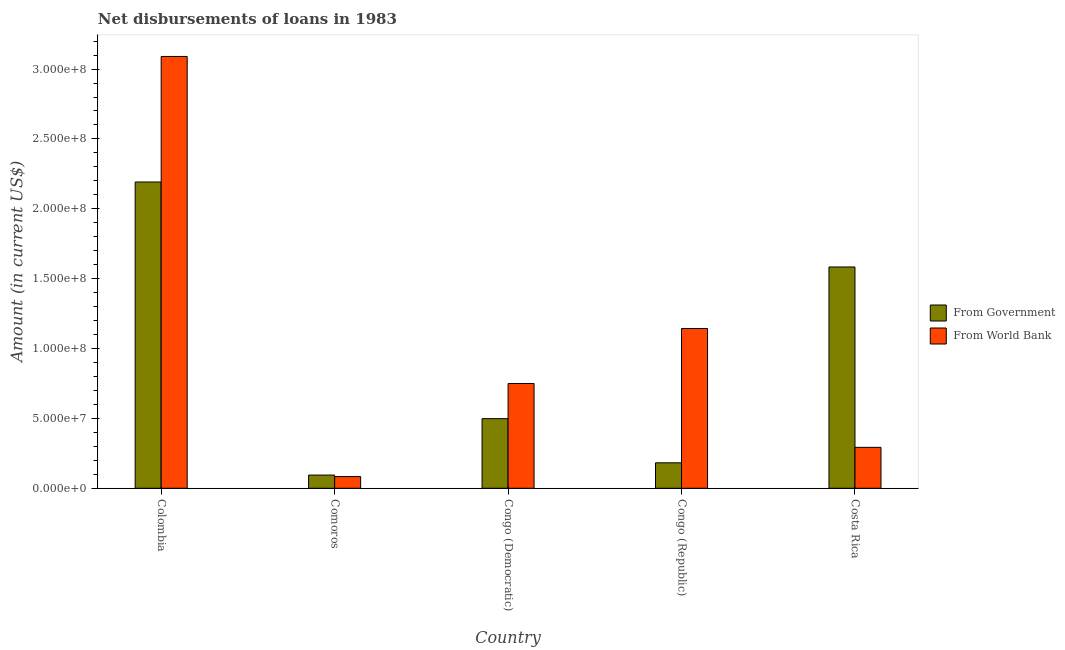How many groups of bars are there?
Your answer should be very brief. 5. Are the number of bars on each tick of the X-axis equal?
Offer a terse response. Yes. How many bars are there on the 3rd tick from the left?
Keep it short and to the point. 2. What is the label of the 4th group of bars from the left?
Your response must be concise. Congo (Republic). In how many cases, is the number of bars for a given country not equal to the number of legend labels?
Ensure brevity in your answer.  0. What is the net disbursements of loan from government in Colombia?
Provide a short and direct response. 2.19e+08. Across all countries, what is the maximum net disbursements of loan from world bank?
Your answer should be very brief. 3.09e+08. Across all countries, what is the minimum net disbursements of loan from world bank?
Offer a very short reply. 8.38e+06. In which country was the net disbursements of loan from world bank maximum?
Your answer should be compact. Colombia. In which country was the net disbursements of loan from government minimum?
Provide a succinct answer. Comoros. What is the total net disbursements of loan from world bank in the graph?
Give a very brief answer. 5.36e+08. What is the difference between the net disbursements of loan from government in Congo (Democratic) and that in Costa Rica?
Give a very brief answer. -1.09e+08. What is the difference between the net disbursements of loan from world bank in Congo (Republic) and the net disbursements of loan from government in Costa Rica?
Provide a succinct answer. -4.40e+07. What is the average net disbursements of loan from world bank per country?
Provide a short and direct response. 1.07e+08. What is the difference between the net disbursements of loan from government and net disbursements of loan from world bank in Comoros?
Offer a terse response. 1.07e+06. What is the ratio of the net disbursements of loan from world bank in Comoros to that in Congo (Democratic)?
Give a very brief answer. 0.11. Is the net disbursements of loan from government in Congo (Democratic) less than that in Congo (Republic)?
Offer a terse response. No. Is the difference between the net disbursements of loan from government in Congo (Republic) and Costa Rica greater than the difference between the net disbursements of loan from world bank in Congo (Republic) and Costa Rica?
Offer a terse response. No. What is the difference between the highest and the second highest net disbursements of loan from government?
Offer a terse response. 6.08e+07. What is the difference between the highest and the lowest net disbursements of loan from government?
Your response must be concise. 2.10e+08. What does the 1st bar from the left in Colombia represents?
Ensure brevity in your answer.  From Government. What does the 1st bar from the right in Congo (Republic) represents?
Your response must be concise. From World Bank. How many countries are there in the graph?
Provide a succinct answer. 5. What is the difference between two consecutive major ticks on the Y-axis?
Offer a terse response. 5.00e+07. Are the values on the major ticks of Y-axis written in scientific E-notation?
Offer a terse response. Yes. Does the graph contain grids?
Provide a succinct answer. No. How are the legend labels stacked?
Offer a terse response. Vertical. What is the title of the graph?
Provide a short and direct response. Net disbursements of loans in 1983. What is the Amount (in current US$) in From Government in Colombia?
Make the answer very short. 2.19e+08. What is the Amount (in current US$) in From World Bank in Colombia?
Provide a short and direct response. 3.09e+08. What is the Amount (in current US$) in From Government in Comoros?
Keep it short and to the point. 9.45e+06. What is the Amount (in current US$) in From World Bank in Comoros?
Keep it short and to the point. 8.38e+06. What is the Amount (in current US$) in From Government in Congo (Democratic)?
Keep it short and to the point. 4.98e+07. What is the Amount (in current US$) of From World Bank in Congo (Democratic)?
Give a very brief answer. 7.50e+07. What is the Amount (in current US$) in From Government in Congo (Republic)?
Your answer should be very brief. 1.82e+07. What is the Amount (in current US$) of From World Bank in Congo (Republic)?
Make the answer very short. 1.14e+08. What is the Amount (in current US$) in From Government in Costa Rica?
Keep it short and to the point. 1.58e+08. What is the Amount (in current US$) of From World Bank in Costa Rica?
Provide a succinct answer. 2.93e+07. Across all countries, what is the maximum Amount (in current US$) of From Government?
Your answer should be very brief. 2.19e+08. Across all countries, what is the maximum Amount (in current US$) of From World Bank?
Your response must be concise. 3.09e+08. Across all countries, what is the minimum Amount (in current US$) in From Government?
Offer a very short reply. 9.45e+06. Across all countries, what is the minimum Amount (in current US$) in From World Bank?
Give a very brief answer. 8.38e+06. What is the total Amount (in current US$) of From Government in the graph?
Your answer should be very brief. 4.55e+08. What is the total Amount (in current US$) of From World Bank in the graph?
Make the answer very short. 5.36e+08. What is the difference between the Amount (in current US$) in From Government in Colombia and that in Comoros?
Your response must be concise. 2.10e+08. What is the difference between the Amount (in current US$) of From World Bank in Colombia and that in Comoros?
Offer a terse response. 3.01e+08. What is the difference between the Amount (in current US$) in From Government in Colombia and that in Congo (Democratic)?
Provide a short and direct response. 1.69e+08. What is the difference between the Amount (in current US$) of From World Bank in Colombia and that in Congo (Democratic)?
Offer a very short reply. 2.34e+08. What is the difference between the Amount (in current US$) of From Government in Colombia and that in Congo (Republic)?
Provide a short and direct response. 2.01e+08. What is the difference between the Amount (in current US$) in From World Bank in Colombia and that in Congo (Republic)?
Ensure brevity in your answer.  1.95e+08. What is the difference between the Amount (in current US$) in From Government in Colombia and that in Costa Rica?
Your response must be concise. 6.08e+07. What is the difference between the Amount (in current US$) of From World Bank in Colombia and that in Costa Rica?
Ensure brevity in your answer.  2.80e+08. What is the difference between the Amount (in current US$) of From Government in Comoros and that in Congo (Democratic)?
Provide a succinct answer. -4.04e+07. What is the difference between the Amount (in current US$) of From World Bank in Comoros and that in Congo (Democratic)?
Make the answer very short. -6.66e+07. What is the difference between the Amount (in current US$) of From Government in Comoros and that in Congo (Republic)?
Ensure brevity in your answer.  -8.77e+06. What is the difference between the Amount (in current US$) in From World Bank in Comoros and that in Congo (Republic)?
Keep it short and to the point. -1.06e+08. What is the difference between the Amount (in current US$) in From Government in Comoros and that in Costa Rica?
Keep it short and to the point. -1.49e+08. What is the difference between the Amount (in current US$) of From World Bank in Comoros and that in Costa Rica?
Provide a succinct answer. -2.09e+07. What is the difference between the Amount (in current US$) in From Government in Congo (Democratic) and that in Congo (Republic)?
Keep it short and to the point. 3.16e+07. What is the difference between the Amount (in current US$) of From World Bank in Congo (Democratic) and that in Congo (Republic)?
Your response must be concise. -3.93e+07. What is the difference between the Amount (in current US$) in From Government in Congo (Democratic) and that in Costa Rica?
Ensure brevity in your answer.  -1.09e+08. What is the difference between the Amount (in current US$) of From World Bank in Congo (Democratic) and that in Costa Rica?
Provide a succinct answer. 4.57e+07. What is the difference between the Amount (in current US$) in From Government in Congo (Republic) and that in Costa Rica?
Ensure brevity in your answer.  -1.40e+08. What is the difference between the Amount (in current US$) in From World Bank in Congo (Republic) and that in Costa Rica?
Your answer should be compact. 8.50e+07. What is the difference between the Amount (in current US$) in From Government in Colombia and the Amount (in current US$) in From World Bank in Comoros?
Provide a succinct answer. 2.11e+08. What is the difference between the Amount (in current US$) of From Government in Colombia and the Amount (in current US$) of From World Bank in Congo (Democratic)?
Your response must be concise. 1.44e+08. What is the difference between the Amount (in current US$) of From Government in Colombia and the Amount (in current US$) of From World Bank in Congo (Republic)?
Your answer should be compact. 1.05e+08. What is the difference between the Amount (in current US$) of From Government in Colombia and the Amount (in current US$) of From World Bank in Costa Rica?
Offer a very short reply. 1.90e+08. What is the difference between the Amount (in current US$) of From Government in Comoros and the Amount (in current US$) of From World Bank in Congo (Democratic)?
Make the answer very short. -6.55e+07. What is the difference between the Amount (in current US$) in From Government in Comoros and the Amount (in current US$) in From World Bank in Congo (Republic)?
Provide a succinct answer. -1.05e+08. What is the difference between the Amount (in current US$) in From Government in Comoros and the Amount (in current US$) in From World Bank in Costa Rica?
Offer a terse response. -1.98e+07. What is the difference between the Amount (in current US$) in From Government in Congo (Democratic) and the Amount (in current US$) in From World Bank in Congo (Republic)?
Your answer should be very brief. -6.45e+07. What is the difference between the Amount (in current US$) of From Government in Congo (Democratic) and the Amount (in current US$) of From World Bank in Costa Rica?
Provide a short and direct response. 2.05e+07. What is the difference between the Amount (in current US$) of From Government in Congo (Republic) and the Amount (in current US$) of From World Bank in Costa Rica?
Your answer should be very brief. -1.11e+07. What is the average Amount (in current US$) of From Government per country?
Keep it short and to the point. 9.10e+07. What is the average Amount (in current US$) of From World Bank per country?
Offer a terse response. 1.07e+08. What is the difference between the Amount (in current US$) in From Government and Amount (in current US$) in From World Bank in Colombia?
Your response must be concise. -8.98e+07. What is the difference between the Amount (in current US$) of From Government and Amount (in current US$) of From World Bank in Comoros?
Your answer should be very brief. 1.07e+06. What is the difference between the Amount (in current US$) in From Government and Amount (in current US$) in From World Bank in Congo (Democratic)?
Keep it short and to the point. -2.52e+07. What is the difference between the Amount (in current US$) of From Government and Amount (in current US$) of From World Bank in Congo (Republic)?
Provide a succinct answer. -9.61e+07. What is the difference between the Amount (in current US$) of From Government and Amount (in current US$) of From World Bank in Costa Rica?
Provide a succinct answer. 1.29e+08. What is the ratio of the Amount (in current US$) of From Government in Colombia to that in Comoros?
Your response must be concise. 23.19. What is the ratio of the Amount (in current US$) in From World Bank in Colombia to that in Comoros?
Your response must be concise. 36.87. What is the ratio of the Amount (in current US$) of From Government in Colombia to that in Congo (Democratic)?
Give a very brief answer. 4.4. What is the ratio of the Amount (in current US$) in From World Bank in Colombia to that in Congo (Democratic)?
Your answer should be very brief. 4.12. What is the ratio of the Amount (in current US$) in From Government in Colombia to that in Congo (Republic)?
Your answer should be very brief. 12.03. What is the ratio of the Amount (in current US$) in From World Bank in Colombia to that in Congo (Republic)?
Your answer should be very brief. 2.7. What is the ratio of the Amount (in current US$) of From Government in Colombia to that in Costa Rica?
Offer a very short reply. 1.38. What is the ratio of the Amount (in current US$) of From World Bank in Colombia to that in Costa Rica?
Provide a short and direct response. 10.55. What is the ratio of the Amount (in current US$) of From Government in Comoros to that in Congo (Democratic)?
Offer a terse response. 0.19. What is the ratio of the Amount (in current US$) in From World Bank in Comoros to that in Congo (Democratic)?
Your answer should be very brief. 0.11. What is the ratio of the Amount (in current US$) in From Government in Comoros to that in Congo (Republic)?
Provide a short and direct response. 0.52. What is the ratio of the Amount (in current US$) in From World Bank in Comoros to that in Congo (Republic)?
Ensure brevity in your answer.  0.07. What is the ratio of the Amount (in current US$) of From Government in Comoros to that in Costa Rica?
Ensure brevity in your answer.  0.06. What is the ratio of the Amount (in current US$) of From World Bank in Comoros to that in Costa Rica?
Offer a terse response. 0.29. What is the ratio of the Amount (in current US$) of From Government in Congo (Democratic) to that in Congo (Republic)?
Keep it short and to the point. 2.74. What is the ratio of the Amount (in current US$) in From World Bank in Congo (Democratic) to that in Congo (Republic)?
Your answer should be very brief. 0.66. What is the ratio of the Amount (in current US$) in From Government in Congo (Democratic) to that in Costa Rica?
Offer a terse response. 0.31. What is the ratio of the Amount (in current US$) of From World Bank in Congo (Democratic) to that in Costa Rica?
Provide a succinct answer. 2.56. What is the ratio of the Amount (in current US$) of From Government in Congo (Republic) to that in Costa Rica?
Make the answer very short. 0.12. What is the ratio of the Amount (in current US$) of From World Bank in Congo (Republic) to that in Costa Rica?
Provide a short and direct response. 3.9. What is the difference between the highest and the second highest Amount (in current US$) of From Government?
Make the answer very short. 6.08e+07. What is the difference between the highest and the second highest Amount (in current US$) of From World Bank?
Your answer should be compact. 1.95e+08. What is the difference between the highest and the lowest Amount (in current US$) in From Government?
Your answer should be compact. 2.10e+08. What is the difference between the highest and the lowest Amount (in current US$) in From World Bank?
Offer a terse response. 3.01e+08. 